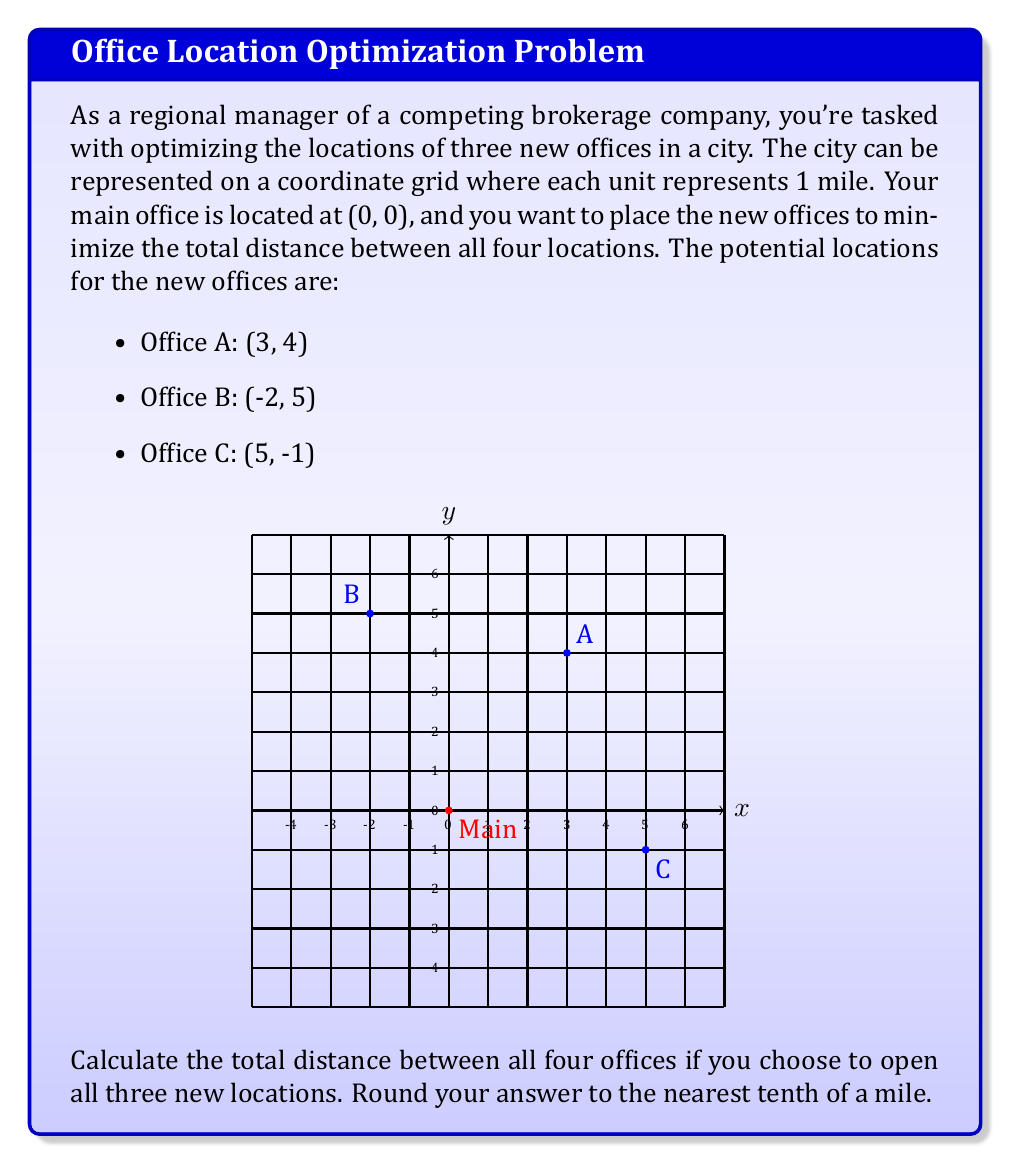Show me your answer to this math problem. To solve this problem, we need to calculate the distances between all pairs of offices and sum them up. We'll use the distance formula:

$$ d = \sqrt{(x_2-x_1)^2 + (y_2-y_1)^2} $$

Let's calculate each distance:

1. Main Office (0,0) to Office A (3,4):
   $d_{MA} = \sqrt{(3-0)^2 + (4-0)^2} = \sqrt{9 + 16} = \sqrt{25} = 5$ miles

2. Main Office (0,0) to Office B (-2,5):
   $d_{MB} = \sqrt{(-2-0)^2 + (5-0)^2} = \sqrt{4 + 25} = \sqrt{29} \approx 5.39$ miles

3. Main Office (0,0) to Office C (5,-1):
   $d_{MC} = \sqrt{(5-0)^2 + (-1-0)^2} = \sqrt{25 + 1} = \sqrt{26} \approx 5.10$ miles

4. Office A (3,4) to Office B (-2,5):
   $d_{AB} = \sqrt{(-2-3)^2 + (5-4)^2} = \sqrt{25 + 1} = \sqrt{26} \approx 5.10$ miles

5. Office A (3,4) to Office C (5,-1):
   $d_{AC} = \sqrt{(5-3)^2 + (-1-4)^2} = \sqrt{4 + 25} = \sqrt{29} \approx 5.39$ miles

6. Office B (-2,5) to Office C (5,-1):
   $d_{BC} = \sqrt{(5-(-2))^2 + (-1-5)^2} = \sqrt{49 + 36} = \sqrt{85} \approx 9.22$ miles

Now, we sum up all these distances:

Total distance = $d_{MA} + d_{MB} + d_{MC} + d_{AB} + d_{AC} + d_{BC}$
                $= 5 + 5.39 + 5.10 + 5.10 + 5.39 + 9.22$
                $= 35.20$ miles

Rounding to the nearest tenth, we get 35.2 miles.
Answer: 35.2 miles 